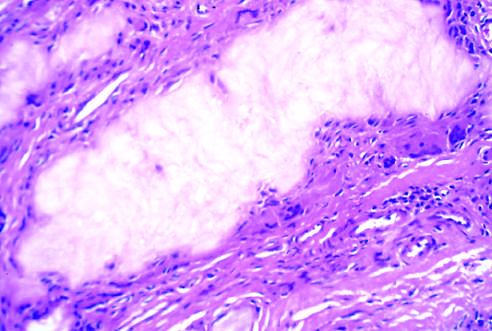re large, flat cells with small nuclei surrounded by reactive fibroblasts, mononuclear inflammatory cells, and giant cells?
Answer the question using a single word or phrase. No 